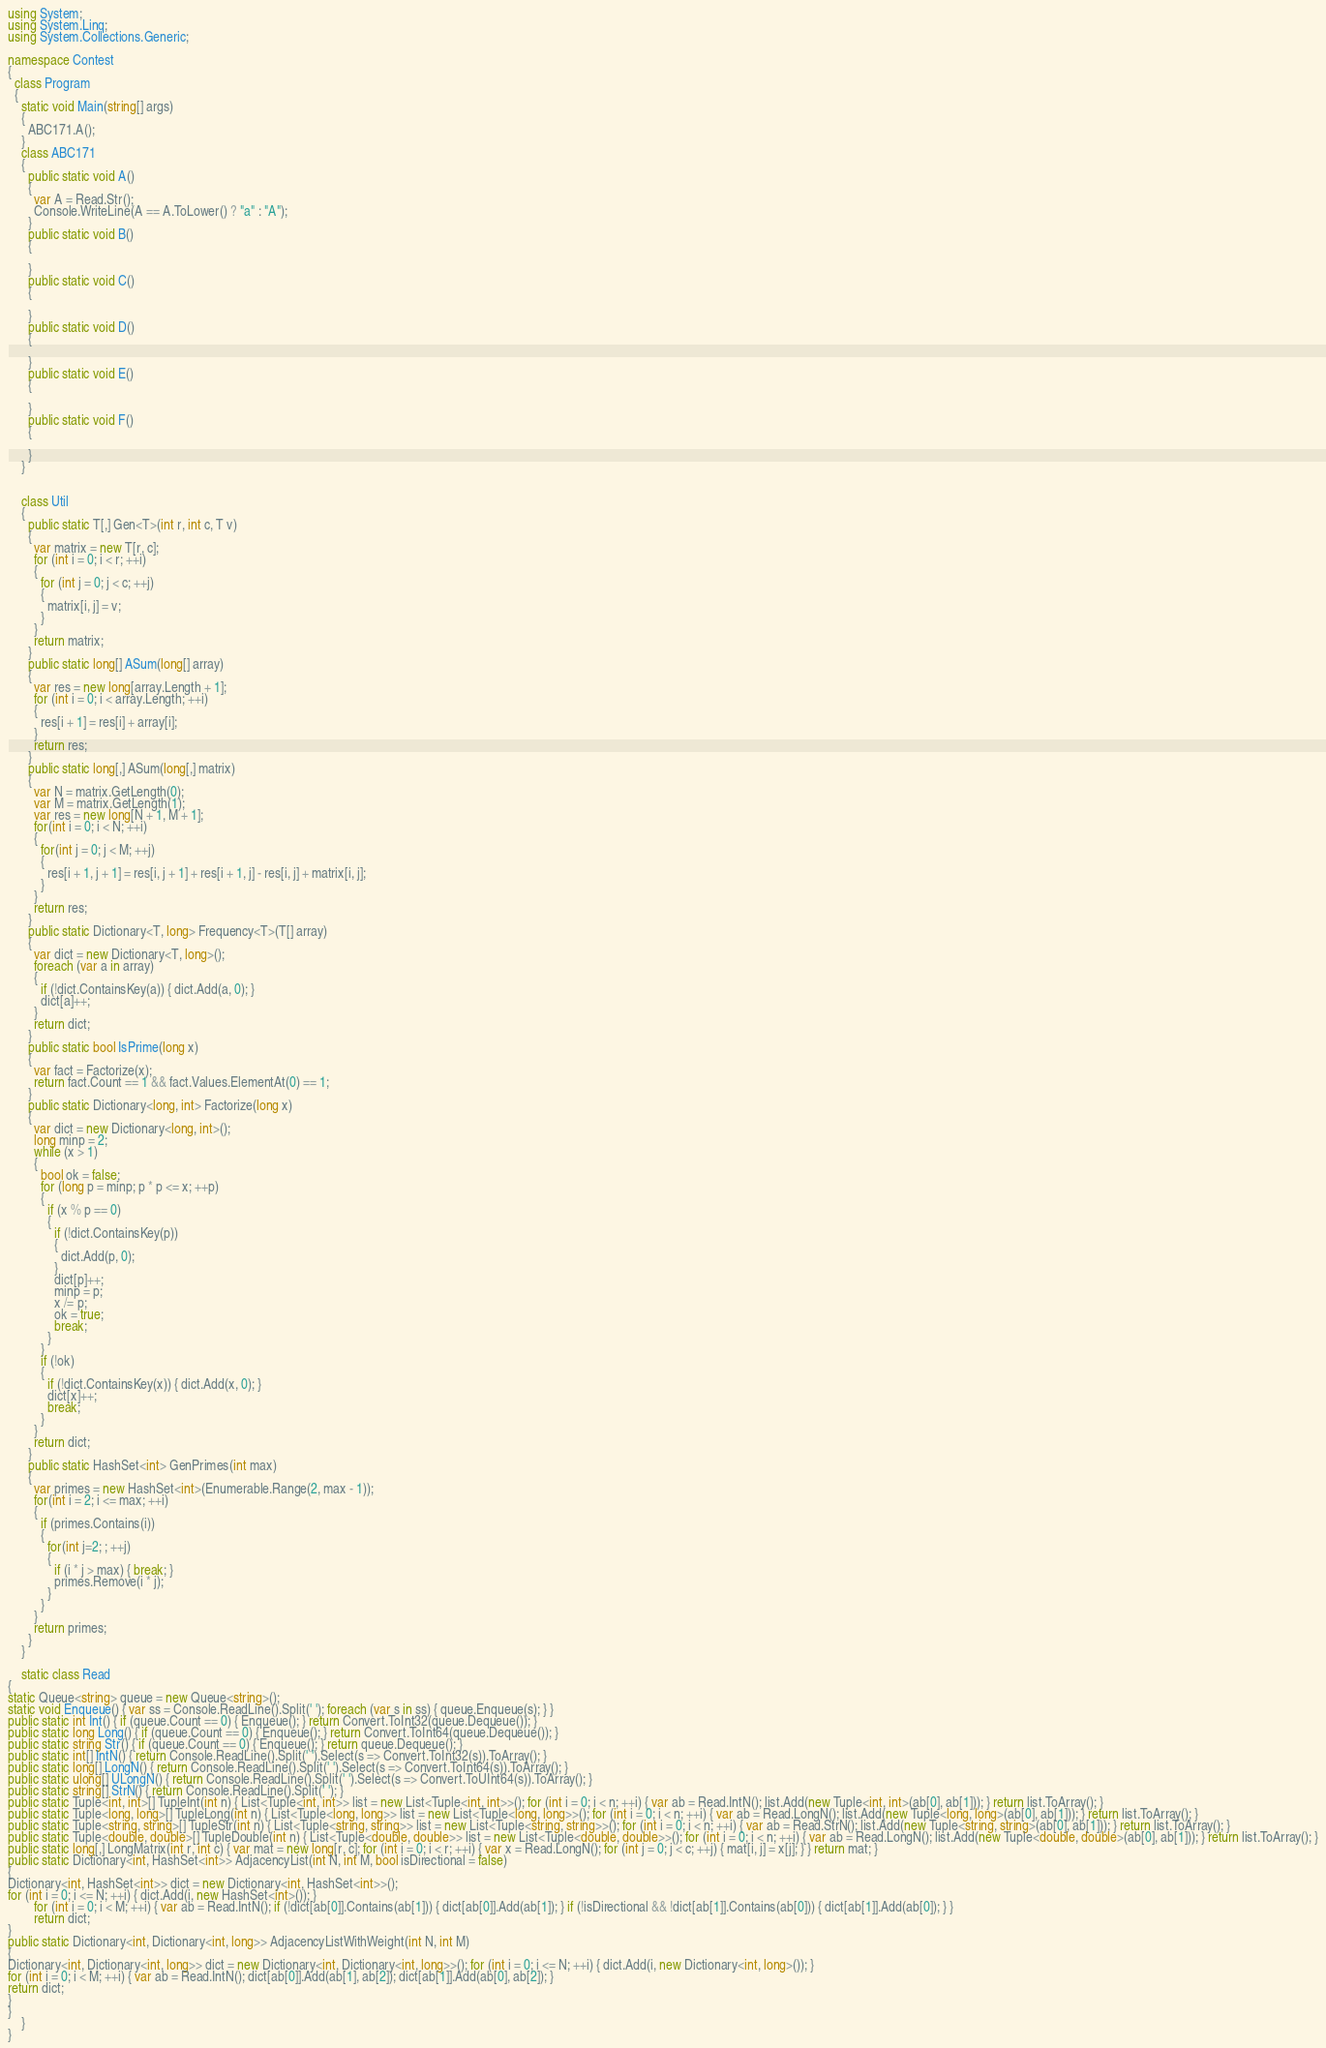Convert code to text. <code><loc_0><loc_0><loc_500><loc_500><_C#_>using System;
using System.Linq;
using System.Collections.Generic;

namespace Contest
{
  class Program
  {
    static void Main(string[] args)
    {
      ABC171.A();
    }
    class ABC171
    {
      public static void A()
      {
        var A = Read.Str();
        Console.WriteLine(A == A.ToLower() ? "a" : "A");
      }
      public static void B()
      {

      }
      public static void C()
      {

      }
      public static void D()
      {

      }
      public static void E()
      {

      }
      public static void F()
      {

      }
    }


    class Util
    {
      public static T[,] Gen<T>(int r, int c, T v)
      {
        var matrix = new T[r, c];
        for (int i = 0; i < r; ++i)
        {
          for (int j = 0; j < c; ++j)
          {
            matrix[i, j] = v;
          }
        }
        return matrix;
      }
      public static long[] ASum(long[] array)
      {
        var res = new long[array.Length + 1];
        for (int i = 0; i < array.Length; ++i)
        {
          res[i + 1] = res[i] + array[i];
        }
        return res;
      }
      public static long[,] ASum(long[,] matrix)
      {
        var N = matrix.GetLength(0);
        var M = matrix.GetLength(1);
        var res = new long[N + 1, M + 1];
        for(int i = 0; i < N; ++i)
        {
          for(int j = 0; j < M; ++j)
          {
            res[i + 1, j + 1] = res[i, j + 1] + res[i + 1, j] - res[i, j] + matrix[i, j];
          }
        }
        return res;
      }
      public static Dictionary<T, long> Frequency<T>(T[] array)
      {
        var dict = new Dictionary<T, long>();
        foreach (var a in array)
        {
          if (!dict.ContainsKey(a)) { dict.Add(a, 0); }
          dict[a]++;
        }
        return dict;
      }
      public static bool IsPrime(long x)
      {
        var fact = Factorize(x);
        return fact.Count == 1 && fact.Values.ElementAt(0) == 1;
      }
      public static Dictionary<long, int> Factorize(long x)
      {
        var dict = new Dictionary<long, int>();
        long minp = 2;
        while (x > 1)
        {
          bool ok = false;
          for (long p = minp; p * p <= x; ++p)
          {
            if (x % p == 0)
            {
              if (!dict.ContainsKey(p))
              {
                dict.Add(p, 0);
              }
              dict[p]++;
              minp = p;
              x /= p;
              ok = true;
              break;
            }
          }
          if (!ok)
          {
            if (!dict.ContainsKey(x)) { dict.Add(x, 0); }
            dict[x]++;
            break;
          }
        }
        return dict;
      }
      public static HashSet<int> GenPrimes(int max)
      {
        var primes = new HashSet<int>(Enumerable.Range(2, max - 1));
        for(int i = 2; i <= max; ++i)
        {
          if (primes.Contains(i))
          {
            for(int j=2; ; ++j)
            {
              if (i * j > max) { break; }
              primes.Remove(i * j);
            }
          }
        }
        return primes;
      }
    }

    static class Read
{
static Queue<string> queue = new Queue<string>();
static void Enqueue() { var ss = Console.ReadLine().Split(' '); foreach (var s in ss) { queue.Enqueue(s); } }
public static int Int() { if (queue.Count == 0) { Enqueue(); } return Convert.ToInt32(queue.Dequeue()); }
public static long Long() { if (queue.Count == 0) { Enqueue(); } return Convert.ToInt64(queue.Dequeue()); }
public static string Str() { if (queue.Count == 0) { Enqueue(); } return queue.Dequeue(); }
public static int[] IntN() { return Console.ReadLine().Split(' ').Select(s => Convert.ToInt32(s)).ToArray(); }
public static long[] LongN() { return Console.ReadLine().Split(' ').Select(s => Convert.ToInt64(s)).ToArray(); }
public static ulong[] ULongN() { return Console.ReadLine().Split(' ').Select(s => Convert.ToUInt64(s)).ToArray(); }
public static string[] StrN() { return Console.ReadLine().Split(' '); }
public static Tuple<int, int>[] TupleInt(int n) { List<Tuple<int, int>> list = new List<Tuple<int, int>>(); for (int i = 0; i < n; ++i) { var ab = Read.IntN(); list.Add(new Tuple<int, int>(ab[0], ab[1])); } return list.ToArray(); }
public static Tuple<long, long>[] TupleLong(int n) { List<Tuple<long, long>> list = new List<Tuple<long, long>>(); for (int i = 0; i < n; ++i) { var ab = Read.LongN(); list.Add(new Tuple<long, long>(ab[0], ab[1])); } return list.ToArray(); }
public static Tuple<string, string>[] TupleStr(int n) { List<Tuple<string, string>> list = new List<Tuple<string, string>>(); for (int i = 0; i < n; ++i) { var ab = Read.StrN(); list.Add(new Tuple<string, string>(ab[0], ab[1])); } return list.ToArray(); }
public static Tuple<double, double>[] TupleDouble(int n) { List<Tuple<double, double>> list = new List<Tuple<double, double>>(); for (int i = 0; i < n; ++i) { var ab = Read.LongN(); list.Add(new Tuple<double, double>(ab[0], ab[1])); } return list.ToArray(); }
public static long[,] LongMatrix(int r, int c) { var mat = new long[r, c]; for (int i = 0; i < r; ++i) { var x = Read.LongN(); for (int j = 0; j < c; ++j) { mat[i, j] = x[j]; } } return mat; }
public static Dictionary<int, HashSet<int>> AdjacencyList(int N, int M, bool isDirectional = false)
{
Dictionary<int, HashSet<int>> dict = new Dictionary<int, HashSet<int>>();
for (int i = 0; i <= N; ++i) { dict.Add(i, new HashSet<int>()); }
        for (int i = 0; i < M; ++i) { var ab = Read.IntN(); if (!dict[ab[0]].Contains(ab[1])) { dict[ab[0]].Add(ab[1]); } if (!isDirectional && !dict[ab[1]].Contains(ab[0])) { dict[ab[1]].Add(ab[0]); } }
        return dict;
}
public static Dictionary<int, Dictionary<int, long>> AdjacencyListWithWeight(int N, int M)
{
Dictionary<int, Dictionary<int, long>> dict = new Dictionary<int, Dictionary<int, long>>(); for (int i = 0; i <= N; ++i) { dict.Add(i, new Dictionary<int, long>()); }
for (int i = 0; i < M; ++i) { var ab = Read.IntN(); dict[ab[0]].Add(ab[1], ab[2]); dict[ab[1]].Add(ab[0], ab[2]); }
return dict;
}
}
    }
}
</code> 